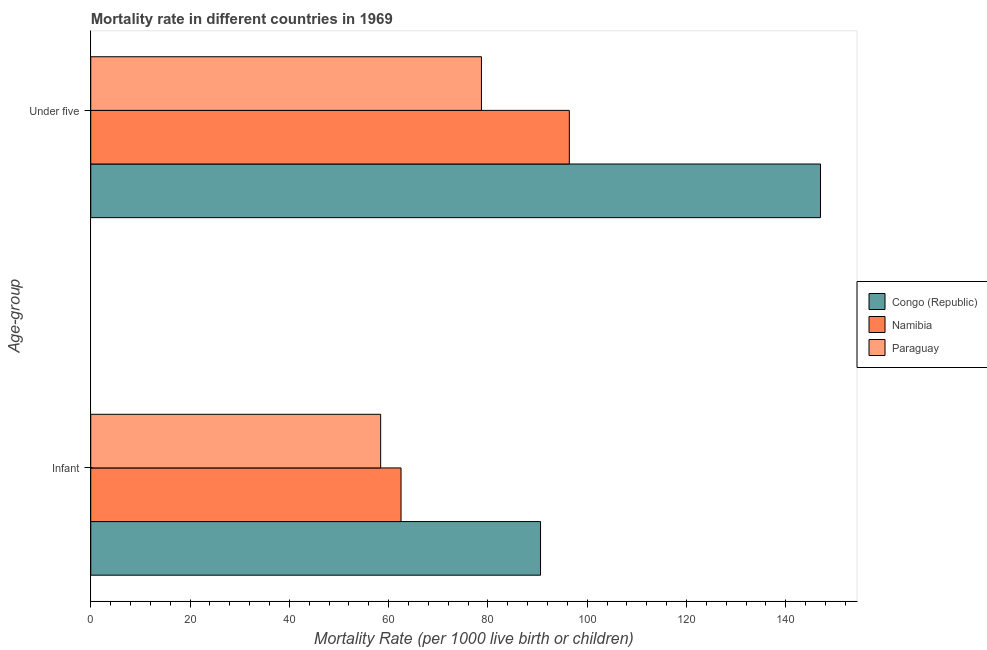How many different coloured bars are there?
Offer a very short reply. 3. Are the number of bars on each tick of the Y-axis equal?
Keep it short and to the point. Yes. How many bars are there on the 2nd tick from the top?
Give a very brief answer. 3. What is the label of the 1st group of bars from the top?
Your answer should be very brief. Under five. What is the infant mortality rate in Congo (Republic)?
Make the answer very short. 90.6. Across all countries, what is the maximum under-5 mortality rate?
Your response must be concise. 147. Across all countries, what is the minimum infant mortality rate?
Ensure brevity in your answer.  58.4. In which country was the under-5 mortality rate maximum?
Ensure brevity in your answer.  Congo (Republic). In which country was the infant mortality rate minimum?
Your answer should be compact. Paraguay. What is the total under-5 mortality rate in the graph?
Your answer should be very brief. 322.1. What is the difference between the infant mortality rate in Congo (Republic) and that in Paraguay?
Your response must be concise. 32.2. What is the difference between the under-5 mortality rate in Congo (Republic) and the infant mortality rate in Namibia?
Your answer should be compact. 84.5. What is the average infant mortality rate per country?
Provide a succinct answer. 70.5. What is the difference between the under-5 mortality rate and infant mortality rate in Paraguay?
Provide a succinct answer. 20.3. What is the ratio of the under-5 mortality rate in Paraguay to that in Namibia?
Keep it short and to the point. 0.82. What does the 3rd bar from the top in Infant represents?
Your answer should be very brief. Congo (Republic). What does the 2nd bar from the bottom in Under five represents?
Provide a succinct answer. Namibia. How many bars are there?
Your answer should be very brief. 6. What is the title of the graph?
Provide a short and direct response. Mortality rate in different countries in 1969. What is the label or title of the X-axis?
Your answer should be compact. Mortality Rate (per 1000 live birth or children). What is the label or title of the Y-axis?
Your response must be concise. Age-group. What is the Mortality Rate (per 1000 live birth or children) in Congo (Republic) in Infant?
Offer a terse response. 90.6. What is the Mortality Rate (per 1000 live birth or children) of Namibia in Infant?
Provide a succinct answer. 62.5. What is the Mortality Rate (per 1000 live birth or children) in Paraguay in Infant?
Offer a very short reply. 58.4. What is the Mortality Rate (per 1000 live birth or children) of Congo (Republic) in Under five?
Your answer should be compact. 147. What is the Mortality Rate (per 1000 live birth or children) in Namibia in Under five?
Make the answer very short. 96.4. What is the Mortality Rate (per 1000 live birth or children) in Paraguay in Under five?
Keep it short and to the point. 78.7. Across all Age-group, what is the maximum Mortality Rate (per 1000 live birth or children) in Congo (Republic)?
Provide a short and direct response. 147. Across all Age-group, what is the maximum Mortality Rate (per 1000 live birth or children) in Namibia?
Your answer should be very brief. 96.4. Across all Age-group, what is the maximum Mortality Rate (per 1000 live birth or children) in Paraguay?
Ensure brevity in your answer.  78.7. Across all Age-group, what is the minimum Mortality Rate (per 1000 live birth or children) in Congo (Republic)?
Make the answer very short. 90.6. Across all Age-group, what is the minimum Mortality Rate (per 1000 live birth or children) of Namibia?
Provide a succinct answer. 62.5. Across all Age-group, what is the minimum Mortality Rate (per 1000 live birth or children) of Paraguay?
Your answer should be very brief. 58.4. What is the total Mortality Rate (per 1000 live birth or children) in Congo (Republic) in the graph?
Provide a succinct answer. 237.6. What is the total Mortality Rate (per 1000 live birth or children) in Namibia in the graph?
Give a very brief answer. 158.9. What is the total Mortality Rate (per 1000 live birth or children) in Paraguay in the graph?
Ensure brevity in your answer.  137.1. What is the difference between the Mortality Rate (per 1000 live birth or children) of Congo (Republic) in Infant and that in Under five?
Keep it short and to the point. -56.4. What is the difference between the Mortality Rate (per 1000 live birth or children) in Namibia in Infant and that in Under five?
Ensure brevity in your answer.  -33.9. What is the difference between the Mortality Rate (per 1000 live birth or children) in Paraguay in Infant and that in Under five?
Ensure brevity in your answer.  -20.3. What is the difference between the Mortality Rate (per 1000 live birth or children) in Congo (Republic) in Infant and the Mortality Rate (per 1000 live birth or children) in Paraguay in Under five?
Make the answer very short. 11.9. What is the difference between the Mortality Rate (per 1000 live birth or children) of Namibia in Infant and the Mortality Rate (per 1000 live birth or children) of Paraguay in Under five?
Offer a terse response. -16.2. What is the average Mortality Rate (per 1000 live birth or children) in Congo (Republic) per Age-group?
Ensure brevity in your answer.  118.8. What is the average Mortality Rate (per 1000 live birth or children) in Namibia per Age-group?
Offer a terse response. 79.45. What is the average Mortality Rate (per 1000 live birth or children) in Paraguay per Age-group?
Offer a terse response. 68.55. What is the difference between the Mortality Rate (per 1000 live birth or children) in Congo (Republic) and Mortality Rate (per 1000 live birth or children) in Namibia in Infant?
Give a very brief answer. 28.1. What is the difference between the Mortality Rate (per 1000 live birth or children) in Congo (Republic) and Mortality Rate (per 1000 live birth or children) in Paraguay in Infant?
Give a very brief answer. 32.2. What is the difference between the Mortality Rate (per 1000 live birth or children) of Namibia and Mortality Rate (per 1000 live birth or children) of Paraguay in Infant?
Your response must be concise. 4.1. What is the difference between the Mortality Rate (per 1000 live birth or children) in Congo (Republic) and Mortality Rate (per 1000 live birth or children) in Namibia in Under five?
Give a very brief answer. 50.6. What is the difference between the Mortality Rate (per 1000 live birth or children) in Congo (Republic) and Mortality Rate (per 1000 live birth or children) in Paraguay in Under five?
Provide a succinct answer. 68.3. What is the difference between the Mortality Rate (per 1000 live birth or children) in Namibia and Mortality Rate (per 1000 live birth or children) in Paraguay in Under five?
Give a very brief answer. 17.7. What is the ratio of the Mortality Rate (per 1000 live birth or children) of Congo (Republic) in Infant to that in Under five?
Your answer should be very brief. 0.62. What is the ratio of the Mortality Rate (per 1000 live birth or children) in Namibia in Infant to that in Under five?
Your response must be concise. 0.65. What is the ratio of the Mortality Rate (per 1000 live birth or children) in Paraguay in Infant to that in Under five?
Offer a terse response. 0.74. What is the difference between the highest and the second highest Mortality Rate (per 1000 live birth or children) of Congo (Republic)?
Make the answer very short. 56.4. What is the difference between the highest and the second highest Mortality Rate (per 1000 live birth or children) of Namibia?
Keep it short and to the point. 33.9. What is the difference between the highest and the second highest Mortality Rate (per 1000 live birth or children) of Paraguay?
Offer a very short reply. 20.3. What is the difference between the highest and the lowest Mortality Rate (per 1000 live birth or children) in Congo (Republic)?
Give a very brief answer. 56.4. What is the difference between the highest and the lowest Mortality Rate (per 1000 live birth or children) in Namibia?
Give a very brief answer. 33.9. What is the difference between the highest and the lowest Mortality Rate (per 1000 live birth or children) in Paraguay?
Offer a very short reply. 20.3. 